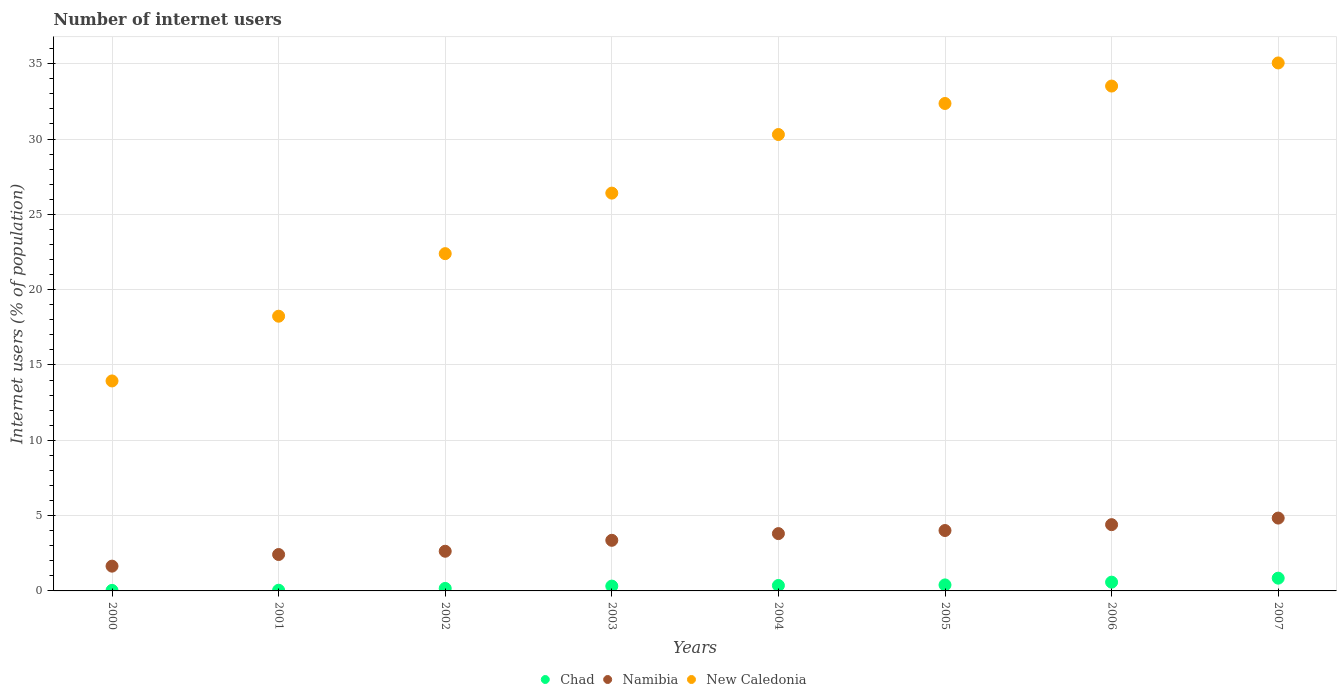What is the number of internet users in Chad in 2003?
Give a very brief answer. 0.32. Across all years, what is the maximum number of internet users in New Caledonia?
Offer a very short reply. 35.05. Across all years, what is the minimum number of internet users in Namibia?
Provide a short and direct response. 1.64. In which year was the number of internet users in Namibia maximum?
Your response must be concise. 2007. What is the total number of internet users in Namibia in the graph?
Your response must be concise. 27.1. What is the difference between the number of internet users in New Caledonia in 2001 and that in 2002?
Make the answer very short. -4.15. What is the difference between the number of internet users in New Caledonia in 2005 and the number of internet users in Chad in 2001?
Offer a terse response. 32.31. What is the average number of internet users in Chad per year?
Ensure brevity in your answer.  0.34. In the year 2007, what is the difference between the number of internet users in Namibia and number of internet users in New Caledonia?
Your response must be concise. -30.21. What is the ratio of the number of internet users in Chad in 2002 to that in 2005?
Give a very brief answer. 0.42. Is the number of internet users in New Caledonia in 2004 less than that in 2005?
Provide a succinct answer. Yes. Is the difference between the number of internet users in Namibia in 2001 and 2003 greater than the difference between the number of internet users in New Caledonia in 2001 and 2003?
Provide a short and direct response. Yes. What is the difference between the highest and the second highest number of internet users in Chad?
Keep it short and to the point. 0.27. What is the difference between the highest and the lowest number of internet users in New Caledonia?
Your answer should be compact. 21.11. Is it the case that in every year, the sum of the number of internet users in Namibia and number of internet users in Chad  is greater than the number of internet users in New Caledonia?
Provide a short and direct response. No. How many dotlines are there?
Keep it short and to the point. 3. How many years are there in the graph?
Offer a terse response. 8. How are the legend labels stacked?
Make the answer very short. Horizontal. What is the title of the graph?
Keep it short and to the point. Number of internet users. What is the label or title of the Y-axis?
Offer a terse response. Internet users (% of population). What is the Internet users (% of population) of Chad in 2000?
Keep it short and to the point. 0.04. What is the Internet users (% of population) of Namibia in 2000?
Make the answer very short. 1.64. What is the Internet users (% of population) in New Caledonia in 2000?
Offer a terse response. 13.94. What is the Internet users (% of population) of Chad in 2001?
Offer a very short reply. 0.05. What is the Internet users (% of population) of Namibia in 2001?
Offer a terse response. 2.42. What is the Internet users (% of population) in New Caledonia in 2001?
Ensure brevity in your answer.  18.24. What is the Internet users (% of population) in Chad in 2002?
Make the answer very short. 0.17. What is the Internet users (% of population) of Namibia in 2002?
Keep it short and to the point. 2.63. What is the Internet users (% of population) of New Caledonia in 2002?
Offer a very short reply. 22.39. What is the Internet users (% of population) of Chad in 2003?
Give a very brief answer. 0.32. What is the Internet users (% of population) of Namibia in 2003?
Your answer should be compact. 3.36. What is the Internet users (% of population) in New Caledonia in 2003?
Offer a terse response. 26.41. What is the Internet users (% of population) of Chad in 2004?
Offer a terse response. 0.36. What is the Internet users (% of population) in Namibia in 2004?
Your response must be concise. 3.8. What is the Internet users (% of population) in New Caledonia in 2004?
Keep it short and to the point. 30.3. What is the Internet users (% of population) in Chad in 2005?
Provide a succinct answer. 0.4. What is the Internet users (% of population) in Namibia in 2005?
Ensure brevity in your answer.  4.01. What is the Internet users (% of population) in New Caledonia in 2005?
Your answer should be compact. 32.36. What is the Internet users (% of population) in Chad in 2006?
Your response must be concise. 0.58. What is the Internet users (% of population) in Namibia in 2006?
Give a very brief answer. 4.4. What is the Internet users (% of population) of New Caledonia in 2006?
Your answer should be very brief. 33.52. What is the Internet users (% of population) in Chad in 2007?
Your response must be concise. 0.85. What is the Internet users (% of population) of Namibia in 2007?
Keep it short and to the point. 4.84. What is the Internet users (% of population) of New Caledonia in 2007?
Give a very brief answer. 35.05. Across all years, what is the maximum Internet users (% of population) of Chad?
Ensure brevity in your answer.  0.85. Across all years, what is the maximum Internet users (% of population) of Namibia?
Provide a succinct answer. 4.84. Across all years, what is the maximum Internet users (% of population) in New Caledonia?
Provide a short and direct response. 35.05. Across all years, what is the minimum Internet users (% of population) in Chad?
Offer a terse response. 0.04. Across all years, what is the minimum Internet users (% of population) in Namibia?
Ensure brevity in your answer.  1.64. Across all years, what is the minimum Internet users (% of population) of New Caledonia?
Offer a very short reply. 13.94. What is the total Internet users (% of population) in Chad in the graph?
Your answer should be very brief. 2.76. What is the total Internet users (% of population) in Namibia in the graph?
Provide a succinct answer. 27.1. What is the total Internet users (% of population) in New Caledonia in the graph?
Give a very brief answer. 212.2. What is the difference between the Internet users (% of population) of Chad in 2000 and that in 2001?
Provide a succinct answer. -0.01. What is the difference between the Internet users (% of population) of Namibia in 2000 and that in 2001?
Your response must be concise. -0.77. What is the difference between the Internet users (% of population) of New Caledonia in 2000 and that in 2001?
Offer a very short reply. -4.3. What is the difference between the Internet users (% of population) in Chad in 2000 and that in 2002?
Offer a very short reply. -0.13. What is the difference between the Internet users (% of population) in Namibia in 2000 and that in 2002?
Offer a terse response. -0.99. What is the difference between the Internet users (% of population) of New Caledonia in 2000 and that in 2002?
Provide a succinct answer. -8.45. What is the difference between the Internet users (% of population) in Chad in 2000 and that in 2003?
Provide a short and direct response. -0.28. What is the difference between the Internet users (% of population) in Namibia in 2000 and that in 2003?
Provide a succinct answer. -1.72. What is the difference between the Internet users (% of population) in New Caledonia in 2000 and that in 2003?
Offer a very short reply. -12.47. What is the difference between the Internet users (% of population) of Chad in 2000 and that in 2004?
Your answer should be very brief. -0.33. What is the difference between the Internet users (% of population) in Namibia in 2000 and that in 2004?
Keep it short and to the point. -2.16. What is the difference between the Internet users (% of population) of New Caledonia in 2000 and that in 2004?
Keep it short and to the point. -16.36. What is the difference between the Internet users (% of population) in Chad in 2000 and that in 2005?
Give a very brief answer. -0.36. What is the difference between the Internet users (% of population) of Namibia in 2000 and that in 2005?
Give a very brief answer. -2.37. What is the difference between the Internet users (% of population) of New Caledonia in 2000 and that in 2005?
Make the answer very short. -18.42. What is the difference between the Internet users (% of population) of Chad in 2000 and that in 2006?
Give a very brief answer. -0.55. What is the difference between the Internet users (% of population) of Namibia in 2000 and that in 2006?
Offer a terse response. -2.75. What is the difference between the Internet users (% of population) in New Caledonia in 2000 and that in 2006?
Ensure brevity in your answer.  -19.58. What is the difference between the Internet users (% of population) of Chad in 2000 and that in 2007?
Provide a short and direct response. -0.81. What is the difference between the Internet users (% of population) of Namibia in 2000 and that in 2007?
Make the answer very short. -3.19. What is the difference between the Internet users (% of population) of New Caledonia in 2000 and that in 2007?
Your answer should be compact. -21.11. What is the difference between the Internet users (% of population) in Chad in 2001 and that in 2002?
Your answer should be compact. -0.12. What is the difference between the Internet users (% of population) in Namibia in 2001 and that in 2002?
Keep it short and to the point. -0.22. What is the difference between the Internet users (% of population) of New Caledonia in 2001 and that in 2002?
Keep it short and to the point. -4.15. What is the difference between the Internet users (% of population) of Chad in 2001 and that in 2003?
Offer a terse response. -0.27. What is the difference between the Internet users (% of population) in Namibia in 2001 and that in 2003?
Offer a terse response. -0.94. What is the difference between the Internet users (% of population) in New Caledonia in 2001 and that in 2003?
Give a very brief answer. -8.17. What is the difference between the Internet users (% of population) in Chad in 2001 and that in 2004?
Make the answer very short. -0.32. What is the difference between the Internet users (% of population) of Namibia in 2001 and that in 2004?
Your answer should be compact. -1.39. What is the difference between the Internet users (% of population) of New Caledonia in 2001 and that in 2004?
Your answer should be compact. -12.06. What is the difference between the Internet users (% of population) of Chad in 2001 and that in 2005?
Keep it short and to the point. -0.35. What is the difference between the Internet users (% of population) of Namibia in 2001 and that in 2005?
Provide a succinct answer. -1.59. What is the difference between the Internet users (% of population) in New Caledonia in 2001 and that in 2005?
Provide a short and direct response. -14.12. What is the difference between the Internet users (% of population) in Chad in 2001 and that in 2006?
Give a very brief answer. -0.54. What is the difference between the Internet users (% of population) of Namibia in 2001 and that in 2006?
Provide a short and direct response. -1.98. What is the difference between the Internet users (% of population) of New Caledonia in 2001 and that in 2006?
Give a very brief answer. -15.28. What is the difference between the Internet users (% of population) in Chad in 2001 and that in 2007?
Keep it short and to the point. -0.8. What is the difference between the Internet users (% of population) of Namibia in 2001 and that in 2007?
Give a very brief answer. -2.42. What is the difference between the Internet users (% of population) in New Caledonia in 2001 and that in 2007?
Your response must be concise. -16.81. What is the difference between the Internet users (% of population) of Chad in 2002 and that in 2003?
Your answer should be compact. -0.15. What is the difference between the Internet users (% of population) of Namibia in 2002 and that in 2003?
Make the answer very short. -0.73. What is the difference between the Internet users (% of population) of New Caledonia in 2002 and that in 2003?
Keep it short and to the point. -4.02. What is the difference between the Internet users (% of population) of Chad in 2002 and that in 2004?
Provide a succinct answer. -0.19. What is the difference between the Internet users (% of population) in Namibia in 2002 and that in 2004?
Offer a very short reply. -1.17. What is the difference between the Internet users (% of population) of New Caledonia in 2002 and that in 2004?
Give a very brief answer. -7.91. What is the difference between the Internet users (% of population) of Chad in 2002 and that in 2005?
Offer a very short reply. -0.23. What is the difference between the Internet users (% of population) of Namibia in 2002 and that in 2005?
Make the answer very short. -1.38. What is the difference between the Internet users (% of population) in New Caledonia in 2002 and that in 2005?
Offer a terse response. -9.97. What is the difference between the Internet users (% of population) of Chad in 2002 and that in 2006?
Offer a terse response. -0.41. What is the difference between the Internet users (% of population) in Namibia in 2002 and that in 2006?
Your answer should be compact. -1.77. What is the difference between the Internet users (% of population) of New Caledonia in 2002 and that in 2006?
Your answer should be compact. -11.13. What is the difference between the Internet users (% of population) in Chad in 2002 and that in 2007?
Your answer should be compact. -0.68. What is the difference between the Internet users (% of population) of Namibia in 2002 and that in 2007?
Give a very brief answer. -2.2. What is the difference between the Internet users (% of population) of New Caledonia in 2002 and that in 2007?
Ensure brevity in your answer.  -12.66. What is the difference between the Internet users (% of population) in Chad in 2003 and that in 2004?
Your answer should be compact. -0.04. What is the difference between the Internet users (% of population) of Namibia in 2003 and that in 2004?
Your answer should be very brief. -0.44. What is the difference between the Internet users (% of population) of New Caledonia in 2003 and that in 2004?
Provide a short and direct response. -3.89. What is the difference between the Internet users (% of population) in Chad in 2003 and that in 2005?
Offer a very short reply. -0.08. What is the difference between the Internet users (% of population) in Namibia in 2003 and that in 2005?
Make the answer very short. -0.65. What is the difference between the Internet users (% of population) in New Caledonia in 2003 and that in 2005?
Offer a very short reply. -5.95. What is the difference between the Internet users (% of population) of Chad in 2003 and that in 2006?
Your answer should be compact. -0.26. What is the difference between the Internet users (% of population) in Namibia in 2003 and that in 2006?
Give a very brief answer. -1.04. What is the difference between the Internet users (% of population) in New Caledonia in 2003 and that in 2006?
Ensure brevity in your answer.  -7.11. What is the difference between the Internet users (% of population) of Chad in 2003 and that in 2007?
Provide a short and direct response. -0.53. What is the difference between the Internet users (% of population) of Namibia in 2003 and that in 2007?
Your response must be concise. -1.48. What is the difference between the Internet users (% of population) of New Caledonia in 2003 and that in 2007?
Ensure brevity in your answer.  -8.64. What is the difference between the Internet users (% of population) in Chad in 2004 and that in 2005?
Your response must be concise. -0.04. What is the difference between the Internet users (% of population) of Namibia in 2004 and that in 2005?
Ensure brevity in your answer.  -0.21. What is the difference between the Internet users (% of population) in New Caledonia in 2004 and that in 2005?
Your response must be concise. -2.06. What is the difference between the Internet users (% of population) of Chad in 2004 and that in 2006?
Provide a short and direct response. -0.22. What is the difference between the Internet users (% of population) in Namibia in 2004 and that in 2006?
Ensure brevity in your answer.  -0.59. What is the difference between the Internet users (% of population) in New Caledonia in 2004 and that in 2006?
Provide a succinct answer. -3.22. What is the difference between the Internet users (% of population) of Chad in 2004 and that in 2007?
Keep it short and to the point. -0.49. What is the difference between the Internet users (% of population) in Namibia in 2004 and that in 2007?
Provide a short and direct response. -1.03. What is the difference between the Internet users (% of population) in New Caledonia in 2004 and that in 2007?
Offer a terse response. -4.75. What is the difference between the Internet users (% of population) of Chad in 2005 and that in 2006?
Your answer should be very brief. -0.18. What is the difference between the Internet users (% of population) in Namibia in 2005 and that in 2006?
Your answer should be very brief. -0.39. What is the difference between the Internet users (% of population) of New Caledonia in 2005 and that in 2006?
Your answer should be compact. -1.16. What is the difference between the Internet users (% of population) in Chad in 2005 and that in 2007?
Make the answer very short. -0.45. What is the difference between the Internet users (% of population) of Namibia in 2005 and that in 2007?
Your answer should be compact. -0.83. What is the difference between the Internet users (% of population) in New Caledonia in 2005 and that in 2007?
Ensure brevity in your answer.  -2.69. What is the difference between the Internet users (% of population) in Chad in 2006 and that in 2007?
Keep it short and to the point. -0.27. What is the difference between the Internet users (% of population) of Namibia in 2006 and that in 2007?
Ensure brevity in your answer.  -0.44. What is the difference between the Internet users (% of population) in New Caledonia in 2006 and that in 2007?
Your answer should be compact. -1.53. What is the difference between the Internet users (% of population) of Chad in 2000 and the Internet users (% of population) of Namibia in 2001?
Provide a succinct answer. -2.38. What is the difference between the Internet users (% of population) in Chad in 2000 and the Internet users (% of population) in New Caledonia in 2001?
Keep it short and to the point. -18.2. What is the difference between the Internet users (% of population) in Namibia in 2000 and the Internet users (% of population) in New Caledonia in 2001?
Offer a very short reply. -16.59. What is the difference between the Internet users (% of population) of Chad in 2000 and the Internet users (% of population) of Namibia in 2002?
Keep it short and to the point. -2.6. What is the difference between the Internet users (% of population) of Chad in 2000 and the Internet users (% of population) of New Caledonia in 2002?
Provide a short and direct response. -22.35. What is the difference between the Internet users (% of population) in Namibia in 2000 and the Internet users (% of population) in New Caledonia in 2002?
Your answer should be very brief. -20.75. What is the difference between the Internet users (% of population) of Chad in 2000 and the Internet users (% of population) of Namibia in 2003?
Provide a short and direct response. -3.32. What is the difference between the Internet users (% of population) of Chad in 2000 and the Internet users (% of population) of New Caledonia in 2003?
Provide a succinct answer. -26.37. What is the difference between the Internet users (% of population) of Namibia in 2000 and the Internet users (% of population) of New Caledonia in 2003?
Provide a short and direct response. -24.76. What is the difference between the Internet users (% of population) of Chad in 2000 and the Internet users (% of population) of Namibia in 2004?
Make the answer very short. -3.77. What is the difference between the Internet users (% of population) of Chad in 2000 and the Internet users (% of population) of New Caledonia in 2004?
Ensure brevity in your answer.  -30.26. What is the difference between the Internet users (% of population) in Namibia in 2000 and the Internet users (% of population) in New Caledonia in 2004?
Keep it short and to the point. -28.65. What is the difference between the Internet users (% of population) in Chad in 2000 and the Internet users (% of population) in Namibia in 2005?
Give a very brief answer. -3.97. What is the difference between the Internet users (% of population) of Chad in 2000 and the Internet users (% of population) of New Caledonia in 2005?
Give a very brief answer. -32.32. What is the difference between the Internet users (% of population) in Namibia in 2000 and the Internet users (% of population) in New Caledonia in 2005?
Ensure brevity in your answer.  -30.71. What is the difference between the Internet users (% of population) in Chad in 2000 and the Internet users (% of population) in Namibia in 2006?
Provide a short and direct response. -4.36. What is the difference between the Internet users (% of population) in Chad in 2000 and the Internet users (% of population) in New Caledonia in 2006?
Provide a succinct answer. -33.48. What is the difference between the Internet users (% of population) of Namibia in 2000 and the Internet users (% of population) of New Caledonia in 2006?
Offer a very short reply. -31.87. What is the difference between the Internet users (% of population) of Chad in 2000 and the Internet users (% of population) of Namibia in 2007?
Provide a short and direct response. -4.8. What is the difference between the Internet users (% of population) in Chad in 2000 and the Internet users (% of population) in New Caledonia in 2007?
Provide a short and direct response. -35.01. What is the difference between the Internet users (% of population) in Namibia in 2000 and the Internet users (% of population) in New Caledonia in 2007?
Your answer should be very brief. -33.41. What is the difference between the Internet users (% of population) in Chad in 2001 and the Internet users (% of population) in Namibia in 2002?
Make the answer very short. -2.59. What is the difference between the Internet users (% of population) in Chad in 2001 and the Internet users (% of population) in New Caledonia in 2002?
Provide a succinct answer. -22.34. What is the difference between the Internet users (% of population) in Namibia in 2001 and the Internet users (% of population) in New Caledonia in 2002?
Provide a succinct answer. -19.97. What is the difference between the Internet users (% of population) in Chad in 2001 and the Internet users (% of population) in Namibia in 2003?
Offer a terse response. -3.31. What is the difference between the Internet users (% of population) in Chad in 2001 and the Internet users (% of population) in New Caledonia in 2003?
Your response must be concise. -26.36. What is the difference between the Internet users (% of population) in Namibia in 2001 and the Internet users (% of population) in New Caledonia in 2003?
Your answer should be very brief. -23.99. What is the difference between the Internet users (% of population) of Chad in 2001 and the Internet users (% of population) of Namibia in 2004?
Keep it short and to the point. -3.76. What is the difference between the Internet users (% of population) in Chad in 2001 and the Internet users (% of population) in New Caledonia in 2004?
Keep it short and to the point. -30.25. What is the difference between the Internet users (% of population) of Namibia in 2001 and the Internet users (% of population) of New Caledonia in 2004?
Provide a succinct answer. -27.88. What is the difference between the Internet users (% of population) in Chad in 2001 and the Internet users (% of population) in Namibia in 2005?
Provide a short and direct response. -3.96. What is the difference between the Internet users (% of population) of Chad in 2001 and the Internet users (% of population) of New Caledonia in 2005?
Offer a very short reply. -32.31. What is the difference between the Internet users (% of population) of Namibia in 2001 and the Internet users (% of population) of New Caledonia in 2005?
Make the answer very short. -29.94. What is the difference between the Internet users (% of population) of Chad in 2001 and the Internet users (% of population) of Namibia in 2006?
Ensure brevity in your answer.  -4.35. What is the difference between the Internet users (% of population) in Chad in 2001 and the Internet users (% of population) in New Caledonia in 2006?
Keep it short and to the point. -33.47. What is the difference between the Internet users (% of population) in Namibia in 2001 and the Internet users (% of population) in New Caledonia in 2006?
Provide a succinct answer. -31.1. What is the difference between the Internet users (% of population) of Chad in 2001 and the Internet users (% of population) of Namibia in 2007?
Make the answer very short. -4.79. What is the difference between the Internet users (% of population) in Chad in 2001 and the Internet users (% of population) in New Caledonia in 2007?
Your answer should be very brief. -35. What is the difference between the Internet users (% of population) in Namibia in 2001 and the Internet users (% of population) in New Caledonia in 2007?
Keep it short and to the point. -32.63. What is the difference between the Internet users (% of population) of Chad in 2002 and the Internet users (% of population) of Namibia in 2003?
Your answer should be very brief. -3.19. What is the difference between the Internet users (% of population) of Chad in 2002 and the Internet users (% of population) of New Caledonia in 2003?
Your answer should be very brief. -26.24. What is the difference between the Internet users (% of population) of Namibia in 2002 and the Internet users (% of population) of New Caledonia in 2003?
Provide a succinct answer. -23.77. What is the difference between the Internet users (% of population) in Chad in 2002 and the Internet users (% of population) in Namibia in 2004?
Your response must be concise. -3.64. What is the difference between the Internet users (% of population) of Chad in 2002 and the Internet users (% of population) of New Caledonia in 2004?
Your response must be concise. -30.13. What is the difference between the Internet users (% of population) in Namibia in 2002 and the Internet users (% of population) in New Caledonia in 2004?
Offer a very short reply. -27.66. What is the difference between the Internet users (% of population) of Chad in 2002 and the Internet users (% of population) of Namibia in 2005?
Ensure brevity in your answer.  -3.84. What is the difference between the Internet users (% of population) of Chad in 2002 and the Internet users (% of population) of New Caledonia in 2005?
Your answer should be compact. -32.19. What is the difference between the Internet users (% of population) in Namibia in 2002 and the Internet users (% of population) in New Caledonia in 2005?
Provide a succinct answer. -29.73. What is the difference between the Internet users (% of population) in Chad in 2002 and the Internet users (% of population) in Namibia in 2006?
Make the answer very short. -4.23. What is the difference between the Internet users (% of population) in Chad in 2002 and the Internet users (% of population) in New Caledonia in 2006?
Provide a short and direct response. -33.35. What is the difference between the Internet users (% of population) of Namibia in 2002 and the Internet users (% of population) of New Caledonia in 2006?
Provide a succinct answer. -30.88. What is the difference between the Internet users (% of population) in Chad in 2002 and the Internet users (% of population) in Namibia in 2007?
Your answer should be very brief. -4.67. What is the difference between the Internet users (% of population) in Chad in 2002 and the Internet users (% of population) in New Caledonia in 2007?
Offer a very short reply. -34.88. What is the difference between the Internet users (% of population) of Namibia in 2002 and the Internet users (% of population) of New Caledonia in 2007?
Make the answer very short. -32.42. What is the difference between the Internet users (% of population) of Chad in 2003 and the Internet users (% of population) of Namibia in 2004?
Ensure brevity in your answer.  -3.48. What is the difference between the Internet users (% of population) in Chad in 2003 and the Internet users (% of population) in New Caledonia in 2004?
Ensure brevity in your answer.  -29.98. What is the difference between the Internet users (% of population) in Namibia in 2003 and the Internet users (% of population) in New Caledonia in 2004?
Keep it short and to the point. -26.94. What is the difference between the Internet users (% of population) in Chad in 2003 and the Internet users (% of population) in Namibia in 2005?
Offer a very short reply. -3.69. What is the difference between the Internet users (% of population) of Chad in 2003 and the Internet users (% of population) of New Caledonia in 2005?
Make the answer very short. -32.04. What is the difference between the Internet users (% of population) of Namibia in 2003 and the Internet users (% of population) of New Caledonia in 2005?
Make the answer very short. -29. What is the difference between the Internet users (% of population) in Chad in 2003 and the Internet users (% of population) in Namibia in 2006?
Provide a succinct answer. -4.08. What is the difference between the Internet users (% of population) of Chad in 2003 and the Internet users (% of population) of New Caledonia in 2006?
Ensure brevity in your answer.  -33.2. What is the difference between the Internet users (% of population) in Namibia in 2003 and the Internet users (% of population) in New Caledonia in 2006?
Provide a succinct answer. -30.16. What is the difference between the Internet users (% of population) of Chad in 2003 and the Internet users (% of population) of Namibia in 2007?
Keep it short and to the point. -4.52. What is the difference between the Internet users (% of population) in Chad in 2003 and the Internet users (% of population) in New Caledonia in 2007?
Provide a succinct answer. -34.73. What is the difference between the Internet users (% of population) in Namibia in 2003 and the Internet users (% of population) in New Caledonia in 2007?
Ensure brevity in your answer.  -31.69. What is the difference between the Internet users (% of population) in Chad in 2004 and the Internet users (% of population) in Namibia in 2005?
Provide a short and direct response. -3.65. What is the difference between the Internet users (% of population) of Chad in 2004 and the Internet users (% of population) of New Caledonia in 2005?
Your answer should be very brief. -32. What is the difference between the Internet users (% of population) of Namibia in 2004 and the Internet users (% of population) of New Caledonia in 2005?
Ensure brevity in your answer.  -28.55. What is the difference between the Internet users (% of population) in Chad in 2004 and the Internet users (% of population) in Namibia in 2006?
Your answer should be compact. -4.04. What is the difference between the Internet users (% of population) in Chad in 2004 and the Internet users (% of population) in New Caledonia in 2006?
Your response must be concise. -33.15. What is the difference between the Internet users (% of population) of Namibia in 2004 and the Internet users (% of population) of New Caledonia in 2006?
Offer a terse response. -29.71. What is the difference between the Internet users (% of population) of Chad in 2004 and the Internet users (% of population) of Namibia in 2007?
Offer a terse response. -4.47. What is the difference between the Internet users (% of population) in Chad in 2004 and the Internet users (% of population) in New Caledonia in 2007?
Offer a very short reply. -34.69. What is the difference between the Internet users (% of population) of Namibia in 2004 and the Internet users (% of population) of New Caledonia in 2007?
Keep it short and to the point. -31.25. What is the difference between the Internet users (% of population) of Chad in 2005 and the Internet users (% of population) of Namibia in 2006?
Ensure brevity in your answer.  -4. What is the difference between the Internet users (% of population) of Chad in 2005 and the Internet users (% of population) of New Caledonia in 2006?
Your response must be concise. -33.12. What is the difference between the Internet users (% of population) of Namibia in 2005 and the Internet users (% of population) of New Caledonia in 2006?
Keep it short and to the point. -29.51. What is the difference between the Internet users (% of population) in Chad in 2005 and the Internet users (% of population) in Namibia in 2007?
Your response must be concise. -4.44. What is the difference between the Internet users (% of population) of Chad in 2005 and the Internet users (% of population) of New Caledonia in 2007?
Your answer should be compact. -34.65. What is the difference between the Internet users (% of population) of Namibia in 2005 and the Internet users (% of population) of New Caledonia in 2007?
Provide a short and direct response. -31.04. What is the difference between the Internet users (% of population) in Chad in 2006 and the Internet users (% of population) in Namibia in 2007?
Keep it short and to the point. -4.25. What is the difference between the Internet users (% of population) of Chad in 2006 and the Internet users (% of population) of New Caledonia in 2007?
Offer a very short reply. -34.47. What is the difference between the Internet users (% of population) of Namibia in 2006 and the Internet users (% of population) of New Caledonia in 2007?
Offer a terse response. -30.65. What is the average Internet users (% of population) of Chad per year?
Give a very brief answer. 0.34. What is the average Internet users (% of population) in Namibia per year?
Your answer should be compact. 3.39. What is the average Internet users (% of population) of New Caledonia per year?
Offer a terse response. 26.52. In the year 2000, what is the difference between the Internet users (% of population) of Chad and Internet users (% of population) of Namibia?
Provide a short and direct response. -1.61. In the year 2000, what is the difference between the Internet users (% of population) of Chad and Internet users (% of population) of New Caledonia?
Give a very brief answer. -13.9. In the year 2000, what is the difference between the Internet users (% of population) in Namibia and Internet users (% of population) in New Caledonia?
Your answer should be very brief. -12.29. In the year 2001, what is the difference between the Internet users (% of population) of Chad and Internet users (% of population) of Namibia?
Provide a short and direct response. -2.37. In the year 2001, what is the difference between the Internet users (% of population) of Chad and Internet users (% of population) of New Caledonia?
Ensure brevity in your answer.  -18.19. In the year 2001, what is the difference between the Internet users (% of population) in Namibia and Internet users (% of population) in New Caledonia?
Make the answer very short. -15.82. In the year 2002, what is the difference between the Internet users (% of population) in Chad and Internet users (% of population) in Namibia?
Provide a succinct answer. -2.47. In the year 2002, what is the difference between the Internet users (% of population) of Chad and Internet users (% of population) of New Caledonia?
Your answer should be very brief. -22.22. In the year 2002, what is the difference between the Internet users (% of population) of Namibia and Internet users (% of population) of New Caledonia?
Offer a terse response. -19.76. In the year 2003, what is the difference between the Internet users (% of population) of Chad and Internet users (% of population) of Namibia?
Your answer should be compact. -3.04. In the year 2003, what is the difference between the Internet users (% of population) in Chad and Internet users (% of population) in New Caledonia?
Provide a succinct answer. -26.09. In the year 2003, what is the difference between the Internet users (% of population) in Namibia and Internet users (% of population) in New Caledonia?
Offer a very short reply. -23.05. In the year 2004, what is the difference between the Internet users (% of population) of Chad and Internet users (% of population) of Namibia?
Give a very brief answer. -3.44. In the year 2004, what is the difference between the Internet users (% of population) of Chad and Internet users (% of population) of New Caledonia?
Ensure brevity in your answer.  -29.94. In the year 2004, what is the difference between the Internet users (% of population) of Namibia and Internet users (% of population) of New Caledonia?
Ensure brevity in your answer.  -26.49. In the year 2005, what is the difference between the Internet users (% of population) in Chad and Internet users (% of population) in Namibia?
Keep it short and to the point. -3.61. In the year 2005, what is the difference between the Internet users (% of population) in Chad and Internet users (% of population) in New Caledonia?
Ensure brevity in your answer.  -31.96. In the year 2005, what is the difference between the Internet users (% of population) of Namibia and Internet users (% of population) of New Caledonia?
Your response must be concise. -28.35. In the year 2006, what is the difference between the Internet users (% of population) in Chad and Internet users (% of population) in Namibia?
Ensure brevity in your answer.  -3.82. In the year 2006, what is the difference between the Internet users (% of population) in Chad and Internet users (% of population) in New Caledonia?
Your answer should be very brief. -32.93. In the year 2006, what is the difference between the Internet users (% of population) of Namibia and Internet users (% of population) of New Caledonia?
Provide a succinct answer. -29.12. In the year 2007, what is the difference between the Internet users (% of population) of Chad and Internet users (% of population) of Namibia?
Your response must be concise. -3.99. In the year 2007, what is the difference between the Internet users (% of population) in Chad and Internet users (% of population) in New Caledonia?
Give a very brief answer. -34.2. In the year 2007, what is the difference between the Internet users (% of population) in Namibia and Internet users (% of population) in New Caledonia?
Provide a short and direct response. -30.21. What is the ratio of the Internet users (% of population) of Chad in 2000 to that in 2001?
Keep it short and to the point. 0.78. What is the ratio of the Internet users (% of population) of Namibia in 2000 to that in 2001?
Offer a very short reply. 0.68. What is the ratio of the Internet users (% of population) of New Caledonia in 2000 to that in 2001?
Keep it short and to the point. 0.76. What is the ratio of the Internet users (% of population) in Chad in 2000 to that in 2002?
Your answer should be compact. 0.21. What is the ratio of the Internet users (% of population) of Namibia in 2000 to that in 2002?
Ensure brevity in your answer.  0.62. What is the ratio of the Internet users (% of population) in New Caledonia in 2000 to that in 2002?
Make the answer very short. 0.62. What is the ratio of the Internet users (% of population) in Chad in 2000 to that in 2003?
Offer a very short reply. 0.11. What is the ratio of the Internet users (% of population) in Namibia in 2000 to that in 2003?
Offer a very short reply. 0.49. What is the ratio of the Internet users (% of population) in New Caledonia in 2000 to that in 2003?
Your answer should be compact. 0.53. What is the ratio of the Internet users (% of population) in Chad in 2000 to that in 2004?
Ensure brevity in your answer.  0.1. What is the ratio of the Internet users (% of population) of Namibia in 2000 to that in 2004?
Make the answer very short. 0.43. What is the ratio of the Internet users (% of population) of New Caledonia in 2000 to that in 2004?
Your answer should be very brief. 0.46. What is the ratio of the Internet users (% of population) in Chad in 2000 to that in 2005?
Give a very brief answer. 0.09. What is the ratio of the Internet users (% of population) in Namibia in 2000 to that in 2005?
Provide a succinct answer. 0.41. What is the ratio of the Internet users (% of population) of New Caledonia in 2000 to that in 2005?
Ensure brevity in your answer.  0.43. What is the ratio of the Internet users (% of population) in Chad in 2000 to that in 2006?
Offer a very short reply. 0.06. What is the ratio of the Internet users (% of population) in Namibia in 2000 to that in 2006?
Offer a very short reply. 0.37. What is the ratio of the Internet users (% of population) in New Caledonia in 2000 to that in 2006?
Ensure brevity in your answer.  0.42. What is the ratio of the Internet users (% of population) of Chad in 2000 to that in 2007?
Make the answer very short. 0.04. What is the ratio of the Internet users (% of population) of Namibia in 2000 to that in 2007?
Your response must be concise. 0.34. What is the ratio of the Internet users (% of population) in New Caledonia in 2000 to that in 2007?
Provide a short and direct response. 0.4. What is the ratio of the Internet users (% of population) of Chad in 2001 to that in 2002?
Provide a short and direct response. 0.28. What is the ratio of the Internet users (% of population) of Namibia in 2001 to that in 2002?
Offer a terse response. 0.92. What is the ratio of the Internet users (% of population) in New Caledonia in 2001 to that in 2002?
Provide a short and direct response. 0.81. What is the ratio of the Internet users (% of population) of Chad in 2001 to that in 2003?
Provide a succinct answer. 0.14. What is the ratio of the Internet users (% of population) of Namibia in 2001 to that in 2003?
Your answer should be compact. 0.72. What is the ratio of the Internet users (% of population) in New Caledonia in 2001 to that in 2003?
Offer a terse response. 0.69. What is the ratio of the Internet users (% of population) of Chad in 2001 to that in 2004?
Keep it short and to the point. 0.13. What is the ratio of the Internet users (% of population) in Namibia in 2001 to that in 2004?
Provide a short and direct response. 0.64. What is the ratio of the Internet users (% of population) of New Caledonia in 2001 to that in 2004?
Give a very brief answer. 0.6. What is the ratio of the Internet users (% of population) of Chad in 2001 to that in 2005?
Provide a short and direct response. 0.12. What is the ratio of the Internet users (% of population) in Namibia in 2001 to that in 2005?
Your answer should be compact. 0.6. What is the ratio of the Internet users (% of population) of New Caledonia in 2001 to that in 2005?
Make the answer very short. 0.56. What is the ratio of the Internet users (% of population) of Chad in 2001 to that in 2006?
Give a very brief answer. 0.08. What is the ratio of the Internet users (% of population) in Namibia in 2001 to that in 2006?
Keep it short and to the point. 0.55. What is the ratio of the Internet users (% of population) in New Caledonia in 2001 to that in 2006?
Provide a short and direct response. 0.54. What is the ratio of the Internet users (% of population) of Chad in 2001 to that in 2007?
Your answer should be compact. 0.05. What is the ratio of the Internet users (% of population) of Namibia in 2001 to that in 2007?
Your response must be concise. 0.5. What is the ratio of the Internet users (% of population) in New Caledonia in 2001 to that in 2007?
Your answer should be very brief. 0.52. What is the ratio of the Internet users (% of population) in Chad in 2002 to that in 2003?
Your response must be concise. 0.52. What is the ratio of the Internet users (% of population) of Namibia in 2002 to that in 2003?
Keep it short and to the point. 0.78. What is the ratio of the Internet users (% of population) of New Caledonia in 2002 to that in 2003?
Your answer should be compact. 0.85. What is the ratio of the Internet users (% of population) in Chad in 2002 to that in 2004?
Offer a very short reply. 0.46. What is the ratio of the Internet users (% of population) in Namibia in 2002 to that in 2004?
Ensure brevity in your answer.  0.69. What is the ratio of the Internet users (% of population) of New Caledonia in 2002 to that in 2004?
Ensure brevity in your answer.  0.74. What is the ratio of the Internet users (% of population) of Chad in 2002 to that in 2005?
Give a very brief answer. 0.42. What is the ratio of the Internet users (% of population) of Namibia in 2002 to that in 2005?
Give a very brief answer. 0.66. What is the ratio of the Internet users (% of population) of New Caledonia in 2002 to that in 2005?
Your answer should be compact. 0.69. What is the ratio of the Internet users (% of population) of Chad in 2002 to that in 2006?
Offer a terse response. 0.29. What is the ratio of the Internet users (% of population) in Namibia in 2002 to that in 2006?
Provide a short and direct response. 0.6. What is the ratio of the Internet users (% of population) in New Caledonia in 2002 to that in 2006?
Keep it short and to the point. 0.67. What is the ratio of the Internet users (% of population) of Chad in 2002 to that in 2007?
Keep it short and to the point. 0.2. What is the ratio of the Internet users (% of population) in Namibia in 2002 to that in 2007?
Your answer should be very brief. 0.54. What is the ratio of the Internet users (% of population) of New Caledonia in 2002 to that in 2007?
Provide a short and direct response. 0.64. What is the ratio of the Internet users (% of population) of Chad in 2003 to that in 2004?
Your answer should be compact. 0.89. What is the ratio of the Internet users (% of population) of Namibia in 2003 to that in 2004?
Your response must be concise. 0.88. What is the ratio of the Internet users (% of population) of New Caledonia in 2003 to that in 2004?
Your response must be concise. 0.87. What is the ratio of the Internet users (% of population) of Chad in 2003 to that in 2005?
Your answer should be compact. 0.8. What is the ratio of the Internet users (% of population) in Namibia in 2003 to that in 2005?
Your answer should be very brief. 0.84. What is the ratio of the Internet users (% of population) in New Caledonia in 2003 to that in 2005?
Ensure brevity in your answer.  0.82. What is the ratio of the Internet users (% of population) in Chad in 2003 to that in 2006?
Provide a short and direct response. 0.55. What is the ratio of the Internet users (% of population) in Namibia in 2003 to that in 2006?
Your response must be concise. 0.76. What is the ratio of the Internet users (% of population) of New Caledonia in 2003 to that in 2006?
Keep it short and to the point. 0.79. What is the ratio of the Internet users (% of population) in Chad in 2003 to that in 2007?
Provide a succinct answer. 0.38. What is the ratio of the Internet users (% of population) in Namibia in 2003 to that in 2007?
Make the answer very short. 0.69. What is the ratio of the Internet users (% of population) of New Caledonia in 2003 to that in 2007?
Your response must be concise. 0.75. What is the ratio of the Internet users (% of population) in Chad in 2004 to that in 2005?
Keep it short and to the point. 0.9. What is the ratio of the Internet users (% of population) in Namibia in 2004 to that in 2005?
Make the answer very short. 0.95. What is the ratio of the Internet users (% of population) in New Caledonia in 2004 to that in 2005?
Make the answer very short. 0.94. What is the ratio of the Internet users (% of population) of Chad in 2004 to that in 2006?
Your response must be concise. 0.62. What is the ratio of the Internet users (% of population) of Namibia in 2004 to that in 2006?
Offer a terse response. 0.86. What is the ratio of the Internet users (% of population) in New Caledonia in 2004 to that in 2006?
Keep it short and to the point. 0.9. What is the ratio of the Internet users (% of population) of Chad in 2004 to that in 2007?
Make the answer very short. 0.43. What is the ratio of the Internet users (% of population) in Namibia in 2004 to that in 2007?
Your answer should be compact. 0.79. What is the ratio of the Internet users (% of population) in New Caledonia in 2004 to that in 2007?
Offer a terse response. 0.86. What is the ratio of the Internet users (% of population) in Chad in 2005 to that in 2006?
Ensure brevity in your answer.  0.69. What is the ratio of the Internet users (% of population) of Namibia in 2005 to that in 2006?
Provide a succinct answer. 0.91. What is the ratio of the Internet users (% of population) of New Caledonia in 2005 to that in 2006?
Your answer should be compact. 0.97. What is the ratio of the Internet users (% of population) in Chad in 2005 to that in 2007?
Give a very brief answer. 0.47. What is the ratio of the Internet users (% of population) of Namibia in 2005 to that in 2007?
Give a very brief answer. 0.83. What is the ratio of the Internet users (% of population) in New Caledonia in 2005 to that in 2007?
Provide a succinct answer. 0.92. What is the ratio of the Internet users (% of population) in Chad in 2006 to that in 2007?
Provide a short and direct response. 0.69. What is the ratio of the Internet users (% of population) in Namibia in 2006 to that in 2007?
Your answer should be very brief. 0.91. What is the ratio of the Internet users (% of population) in New Caledonia in 2006 to that in 2007?
Provide a succinct answer. 0.96. What is the difference between the highest and the second highest Internet users (% of population) of Chad?
Provide a succinct answer. 0.27. What is the difference between the highest and the second highest Internet users (% of population) of Namibia?
Make the answer very short. 0.44. What is the difference between the highest and the second highest Internet users (% of population) in New Caledonia?
Your response must be concise. 1.53. What is the difference between the highest and the lowest Internet users (% of population) of Chad?
Make the answer very short. 0.81. What is the difference between the highest and the lowest Internet users (% of population) of Namibia?
Ensure brevity in your answer.  3.19. What is the difference between the highest and the lowest Internet users (% of population) of New Caledonia?
Offer a terse response. 21.11. 